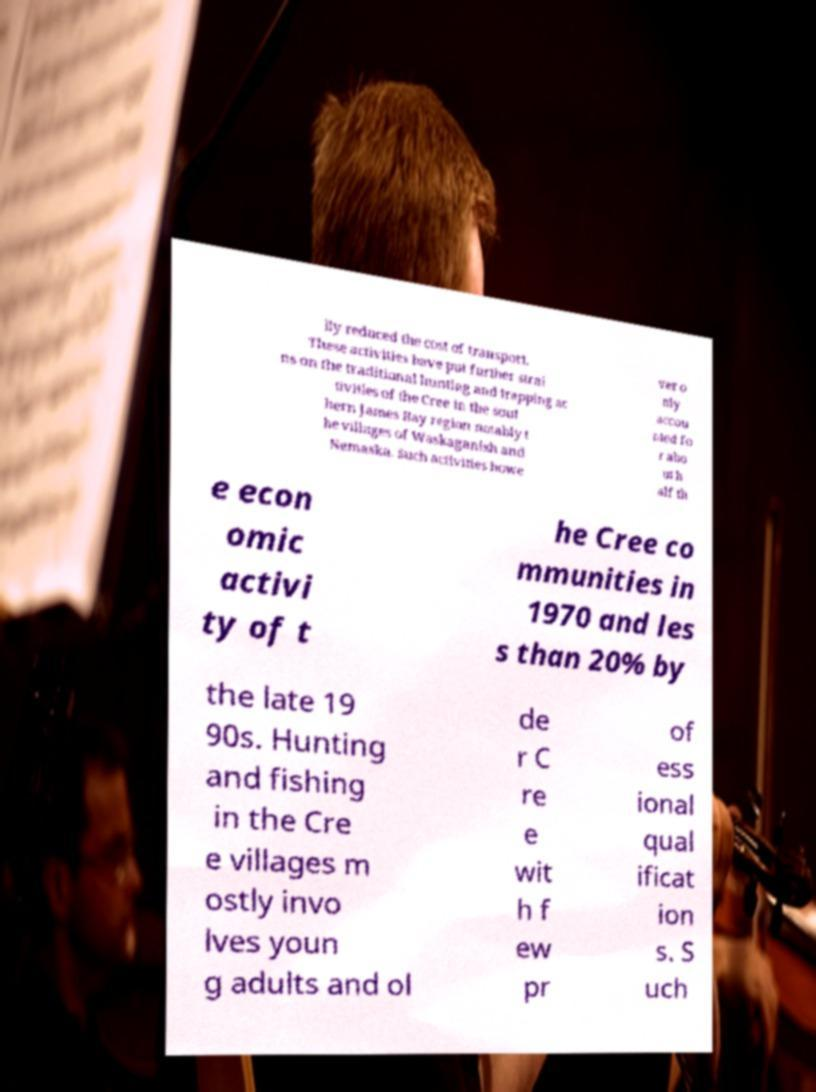Please identify and transcribe the text found in this image. lly reduced the cost of transport. These activities have put further strai ns on the traditional hunting and trapping ac tivities of the Cree in the sout hern James Bay region notably t he villages of Waskaganish and Nemaska. Such activities howe ver o nly accou nted fo r abo ut h alf th e econ omic activi ty of t he Cree co mmunities in 1970 and les s than 20% by the late 19 90s. Hunting and fishing in the Cre e villages m ostly invo lves youn g adults and ol de r C re e wit h f ew pr of ess ional qual ificat ion s. S uch 